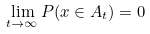Convert formula to latex. <formula><loc_0><loc_0><loc_500><loc_500>\lim _ { t \rightarrow \infty } P ( x \in A _ { t } ) = 0</formula> 